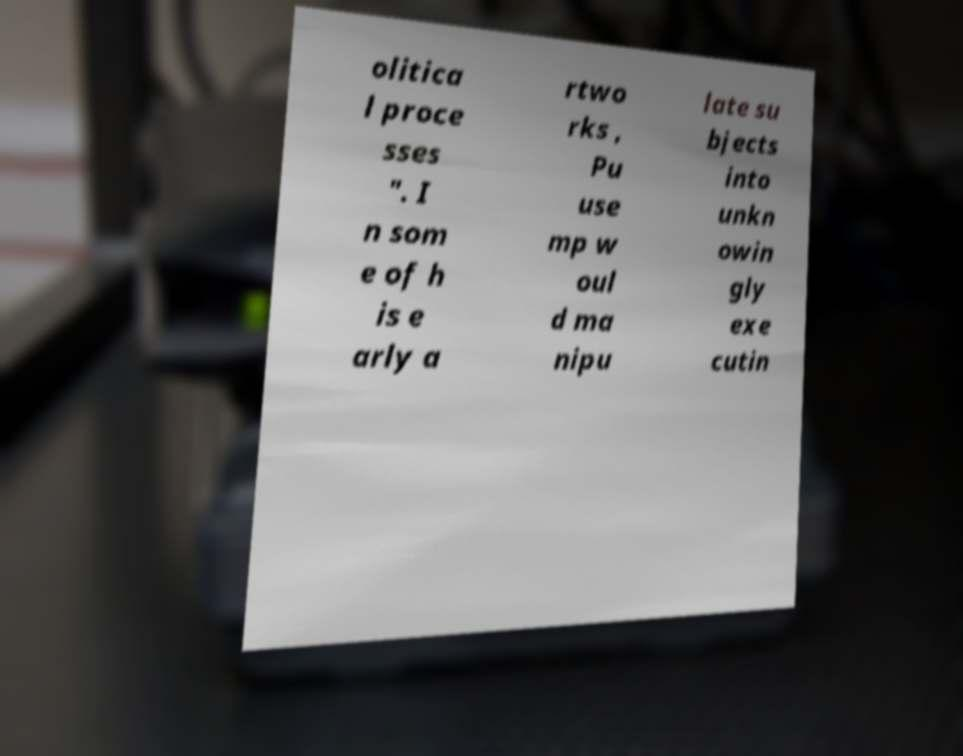Could you extract and type out the text from this image? olitica l proce sses ". I n som e of h is e arly a rtwo rks , Pu use mp w oul d ma nipu late su bjects into unkn owin gly exe cutin 